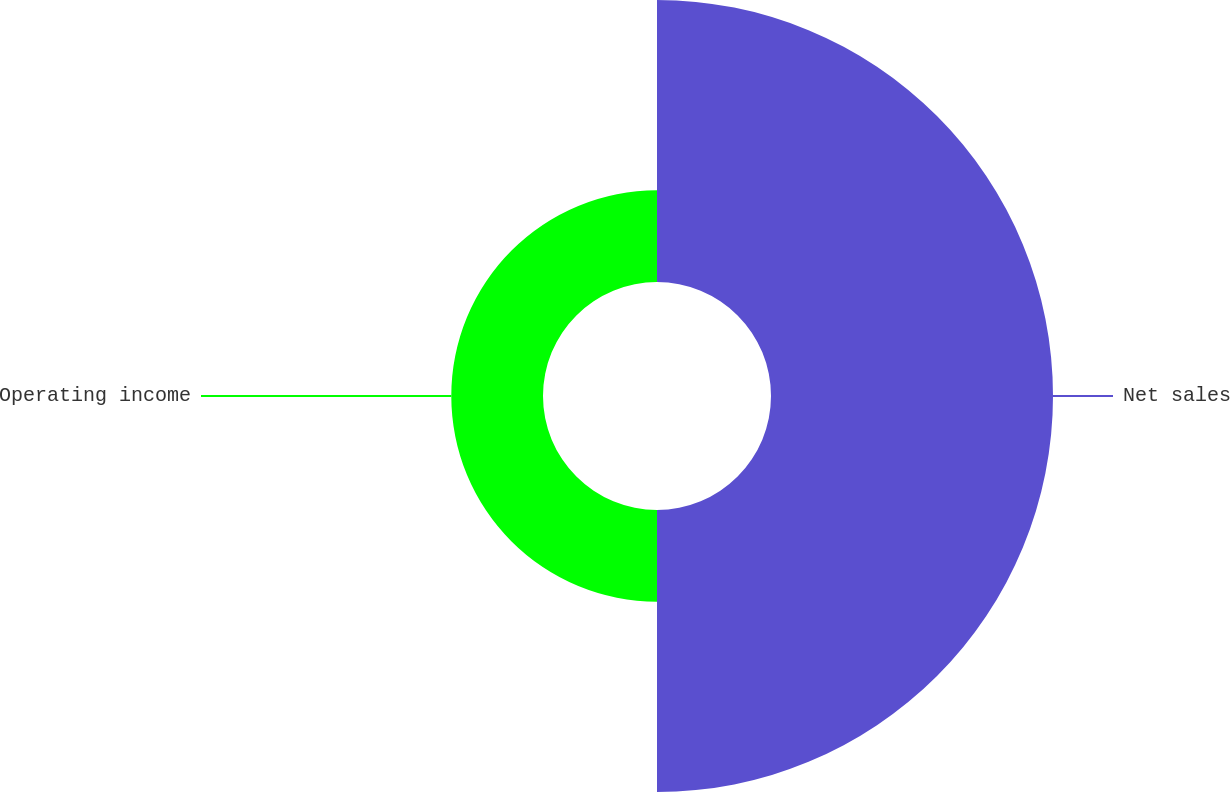Convert chart. <chart><loc_0><loc_0><loc_500><loc_500><pie_chart><fcel>Net sales<fcel>Operating income<nl><fcel>75.46%<fcel>24.54%<nl></chart> 